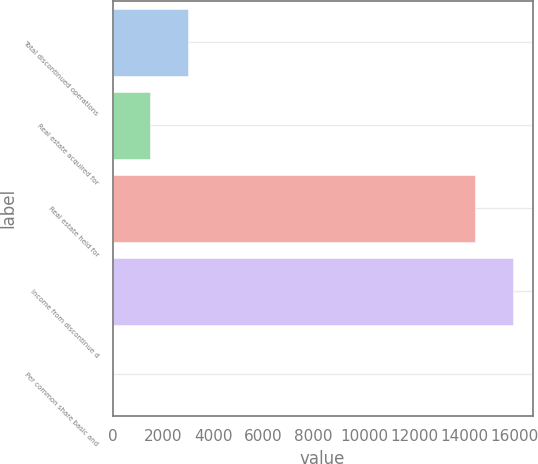<chart> <loc_0><loc_0><loc_500><loc_500><bar_chart><fcel>Total discontinued operations<fcel>Real estate acquired for<fcel>Real estate held for<fcel>Income from discontinue d<fcel>Per common share basic and<nl><fcel>2999.12<fcel>1499.64<fcel>14420<fcel>15919.5<fcel>0.15<nl></chart> 